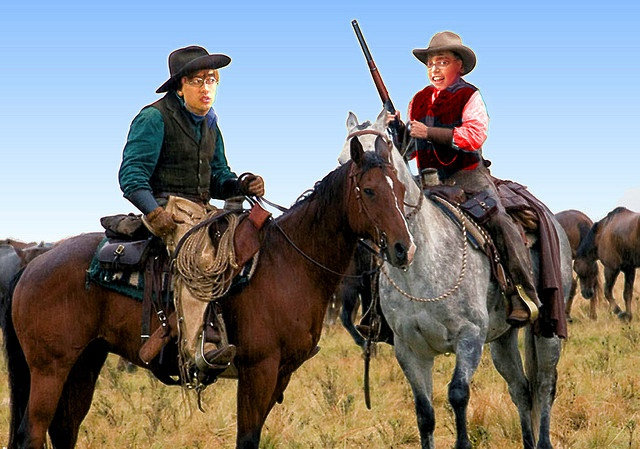Describe the objects in this image and their specific colors. I can see horse in lightblue, black, maroon, and gray tones, horse in lightblue, gray, black, darkgray, and darkgreen tones, people in lightblue, black, teal, maroon, and gray tones, people in lightblue, black, maroon, gray, and white tones, and horse in lightblue, black, maroon, and gray tones in this image. 